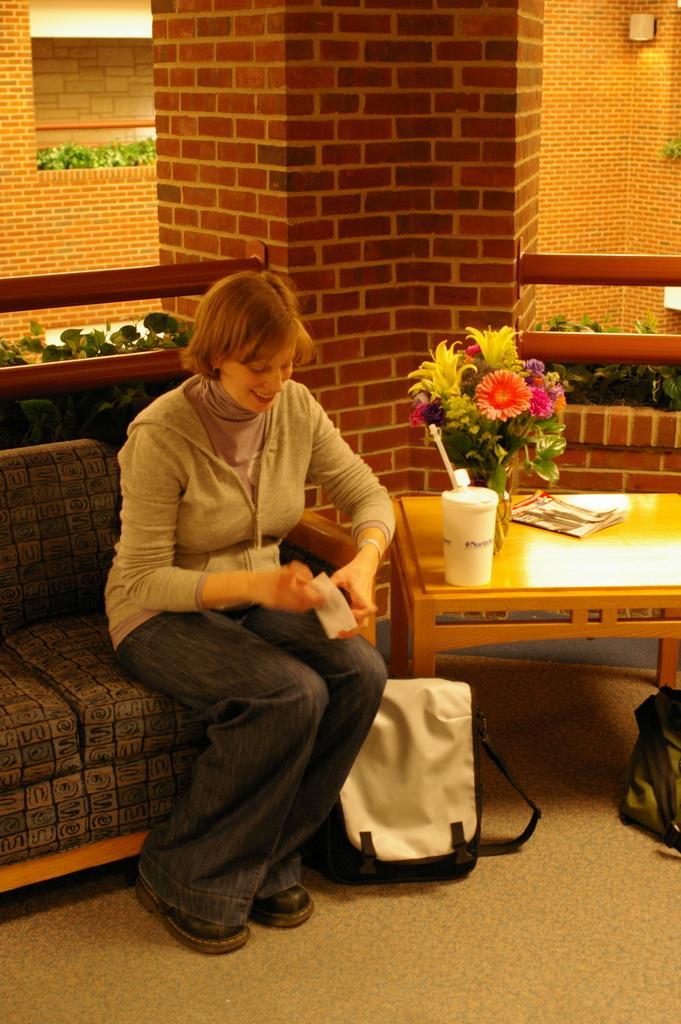Describe this image in one or two sentences. In this image there is a lady person wearing white color shirt sitting on the couch and at the bottom of the image there is a bag and at the right side of the image there is a flower vase and book on the table and at the background of the image there is a brick wall. 